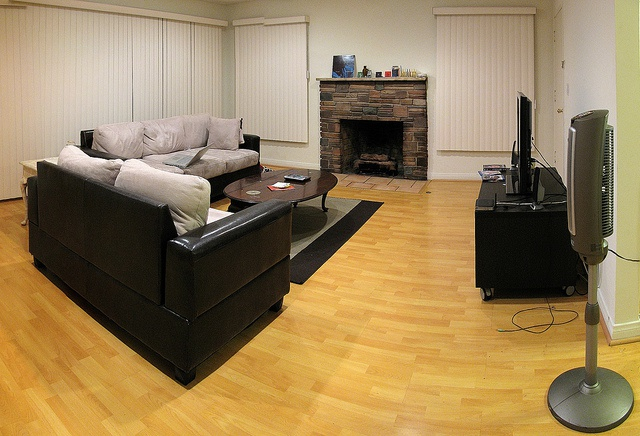Describe the objects in this image and their specific colors. I can see couch in olive, black, and gray tones, couch in olive, darkgray, black, and lightgray tones, tv in olive, black, gray, and lightgray tones, laptop in olive, darkgray, and gray tones, and remote in olive, black, gray, darkgray, and lightgray tones in this image. 